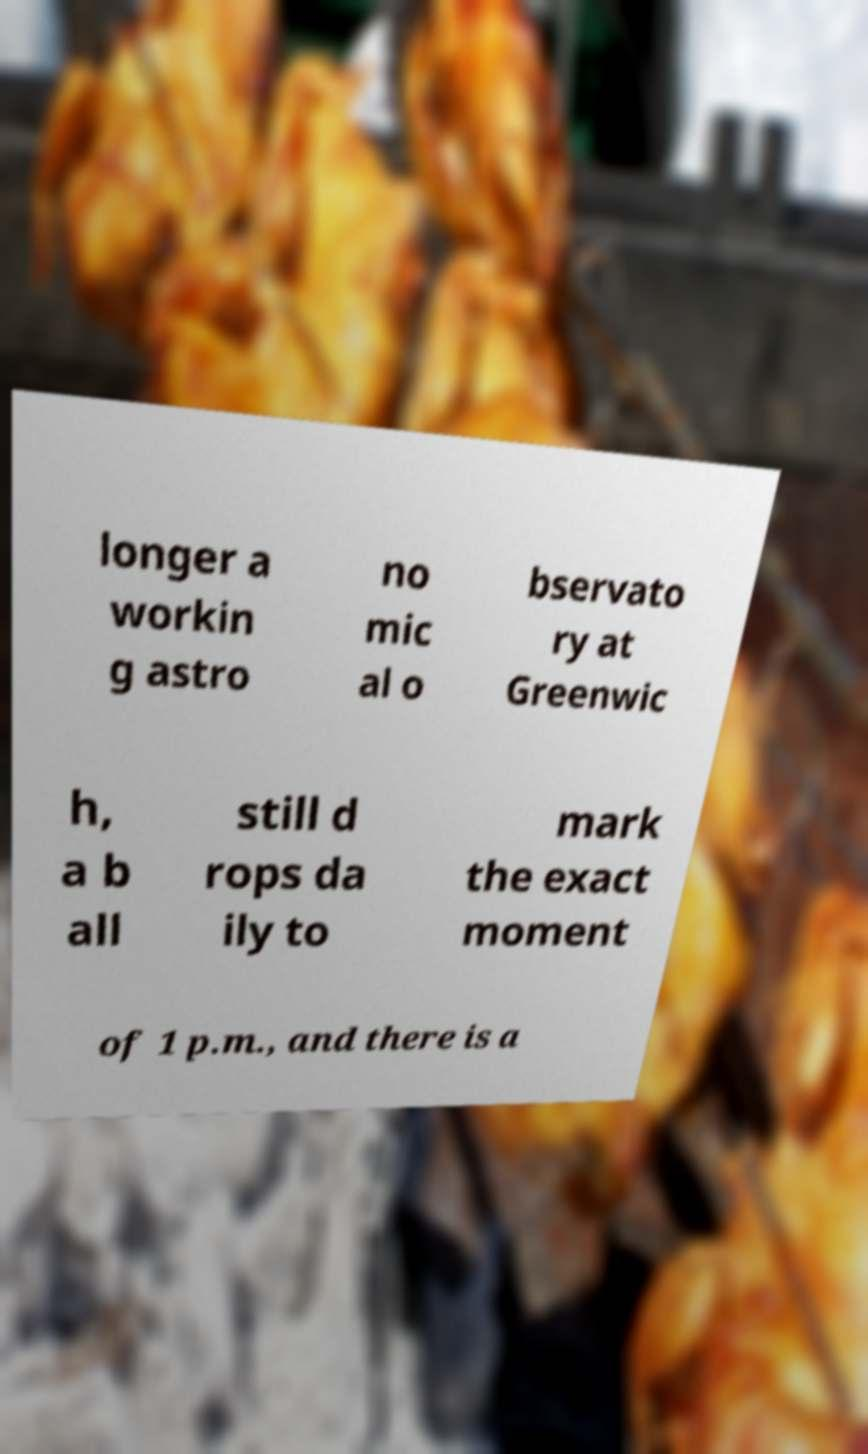There's text embedded in this image that I need extracted. Can you transcribe it verbatim? longer a workin g astro no mic al o bservato ry at Greenwic h, a b all still d rops da ily to mark the exact moment of 1 p.m., and there is a 